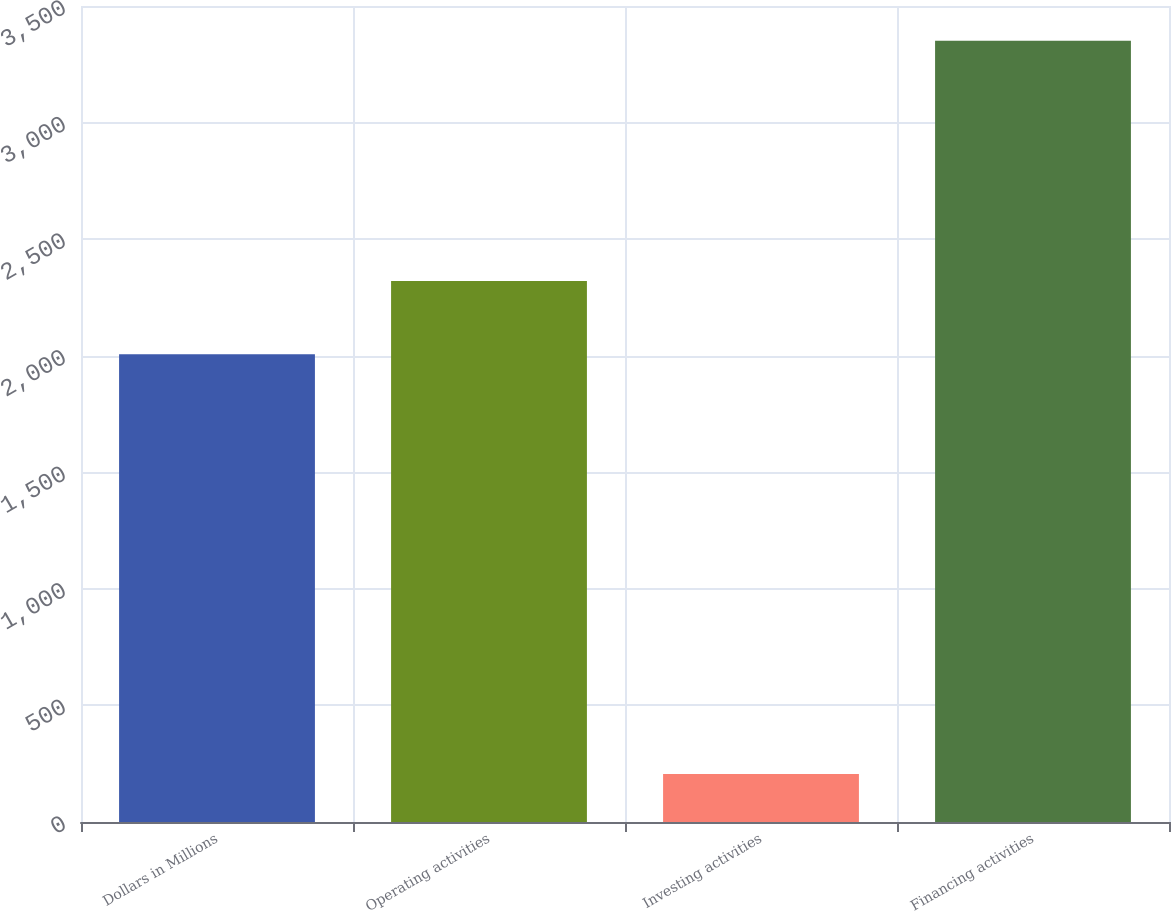Convert chart to OTSL. <chart><loc_0><loc_0><loc_500><loc_500><bar_chart><fcel>Dollars in Millions<fcel>Operating activities<fcel>Investing activities<fcel>Financing activities<nl><fcel>2006<fcel>2320.5<fcel>206<fcel>3351<nl></chart> 